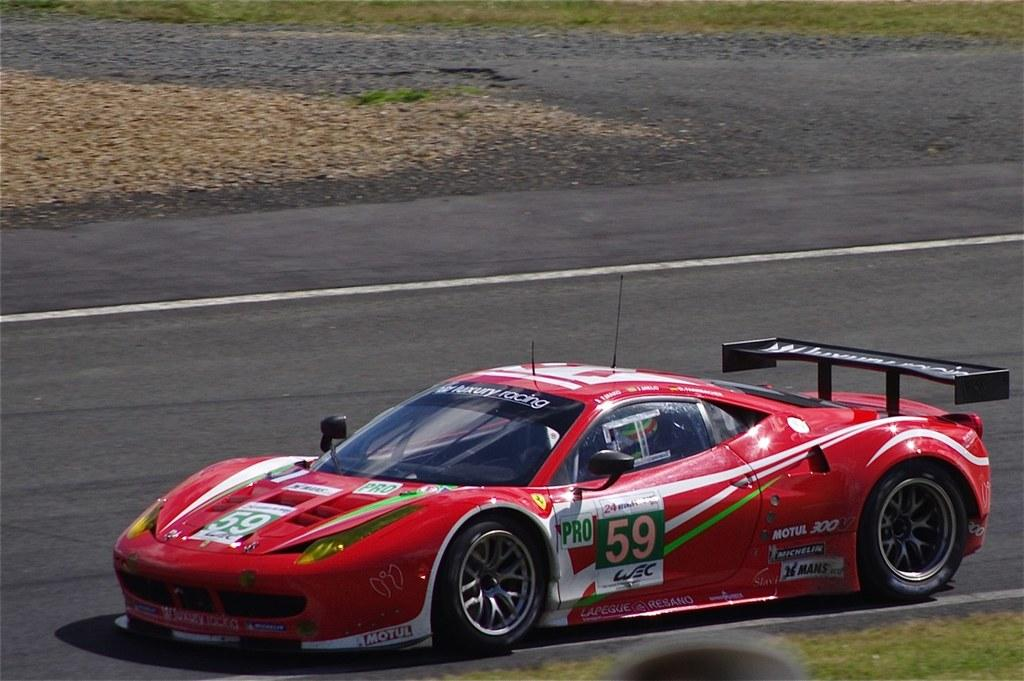What color is the vehicle on the road? The vehicle on the road is red. What marking can be seen on the road? There is a white color line on the road. What type of vegetation is present beside the road? There is grass on the ground beside the road. What type of vegetation is visible in the background? There is grass on the ground in the background. What type of spark can be seen coming from the wrist of the driver in the image? There is no driver or spark present in the image; it only shows a red vehicle on the road and the surrounding environment. 